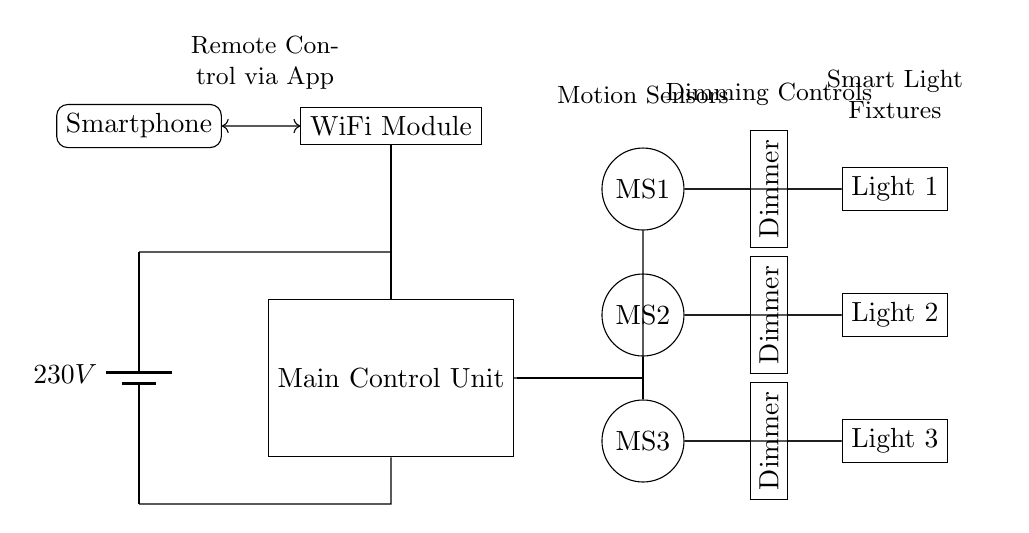What is the voltage of this circuit? The voltage of the circuit is 230 volts, as indicated by the battery symbol at the left of the diagram.
Answer: 230 volts What components control the lights? The components that control the lights are the motion sensors and dimmers, which are connected to the light fixtures, allowing for both automatic activation and brightness adjustment.
Answer: Motion sensors and dimmers How many motion sensors are there? There are three motion sensors depicted in the circuit diagram, labeled as MS1, MS2, and MS3, located on the right side of the main control unit.
Answer: Three What is the purpose of the WiFi module in this circuit? The WiFi module is used for remote control of the lighting system via a smartphone app, allowing the user to interact with the lighting system wirelessly.
Answer: Remote control Which direction do the light fixtures connect to the dimmers? The light fixtures connect to the dimmers via a single line from each dimmer to its corresponding light fixture; this indicates that dimming control is applied before the lights are powered.
Answer: Towards the dimmers What indicates the system has remote control capability? The presence of a smartphone icon connected to the WiFi module demonstrates that the system can be controlled remotely, allowing users to manage their lighting from a mobile device.
Answer: Smartphone How does the motion sensor activate the light fixture? The motion sensor detects movement and sends a signal to the corresponding light fixture, which then turns on the light, as illustrated by the direct connection between each motion sensor and its associated light.
Answer: Signal from motion sensors 